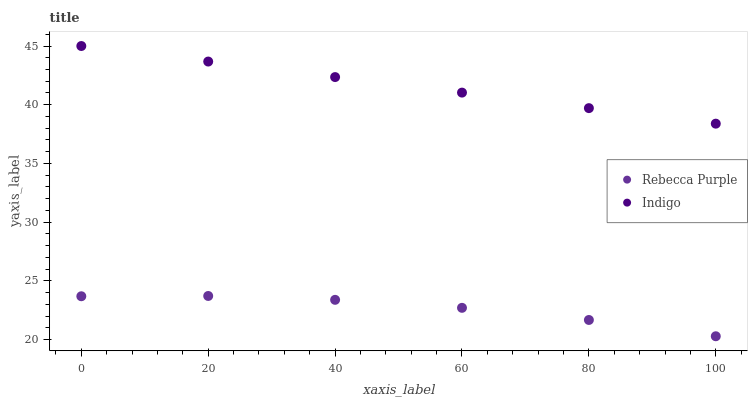Does Rebecca Purple have the minimum area under the curve?
Answer yes or no. Yes. Does Indigo have the maximum area under the curve?
Answer yes or no. Yes. Does Rebecca Purple have the maximum area under the curve?
Answer yes or no. No. Is Indigo the smoothest?
Answer yes or no. Yes. Is Rebecca Purple the roughest?
Answer yes or no. Yes. Is Rebecca Purple the smoothest?
Answer yes or no. No. Does Rebecca Purple have the lowest value?
Answer yes or no. Yes. Does Indigo have the highest value?
Answer yes or no. Yes. Does Rebecca Purple have the highest value?
Answer yes or no. No. Is Rebecca Purple less than Indigo?
Answer yes or no. Yes. Is Indigo greater than Rebecca Purple?
Answer yes or no. Yes. Does Rebecca Purple intersect Indigo?
Answer yes or no. No. 